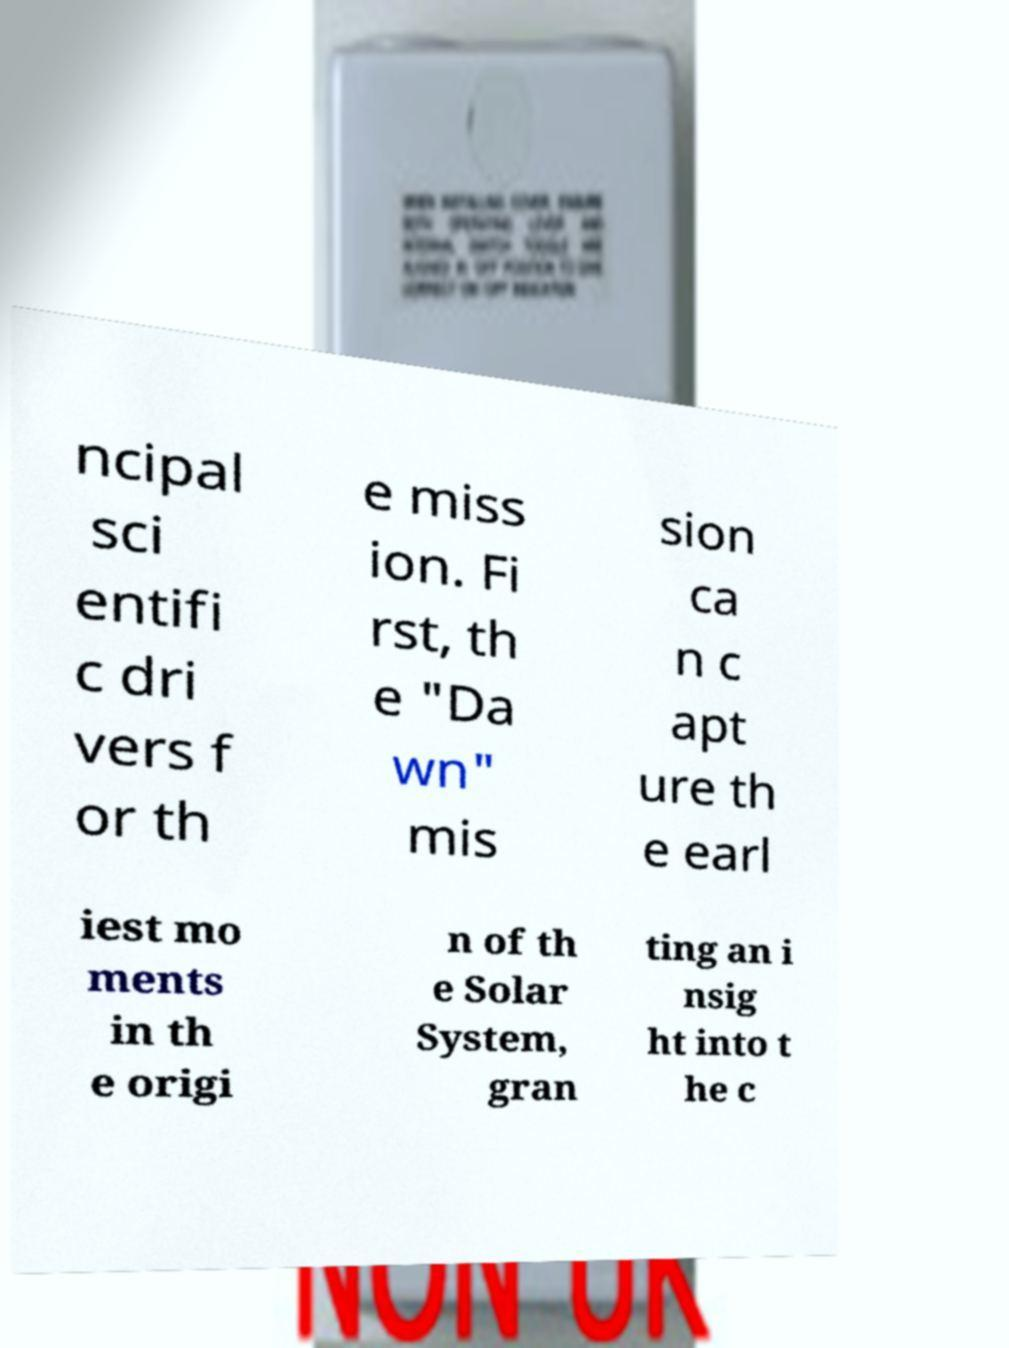For documentation purposes, I need the text within this image transcribed. Could you provide that? ncipal sci entifi c dri vers f or th e miss ion. Fi rst, th e "Da wn" mis sion ca n c apt ure th e earl iest mo ments in th e origi n of th e Solar System, gran ting an i nsig ht into t he c 